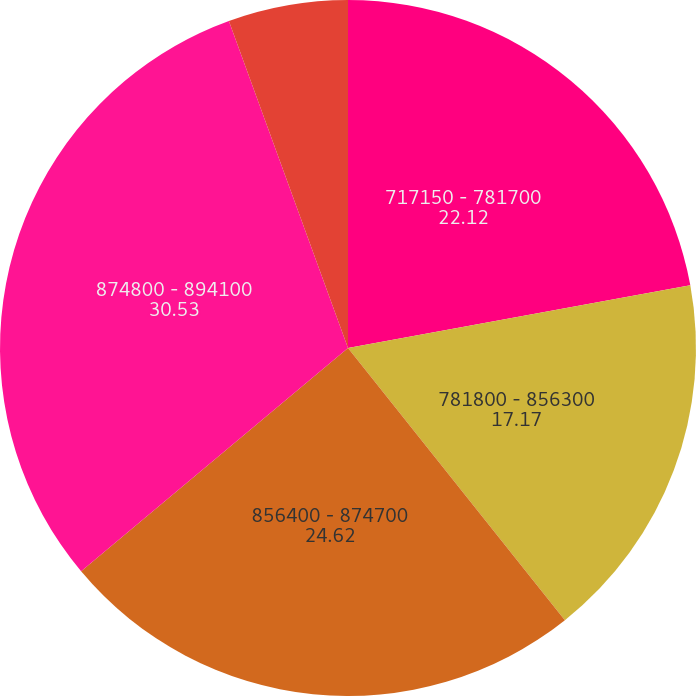<chart> <loc_0><loc_0><loc_500><loc_500><pie_chart><fcel>717150 - 781700<fcel>781800 - 856300<fcel>856400 - 874700<fcel>874800 - 894100<fcel>894200 - 1101300<nl><fcel>22.12%<fcel>17.17%<fcel>24.62%<fcel>30.53%<fcel>5.56%<nl></chart> 